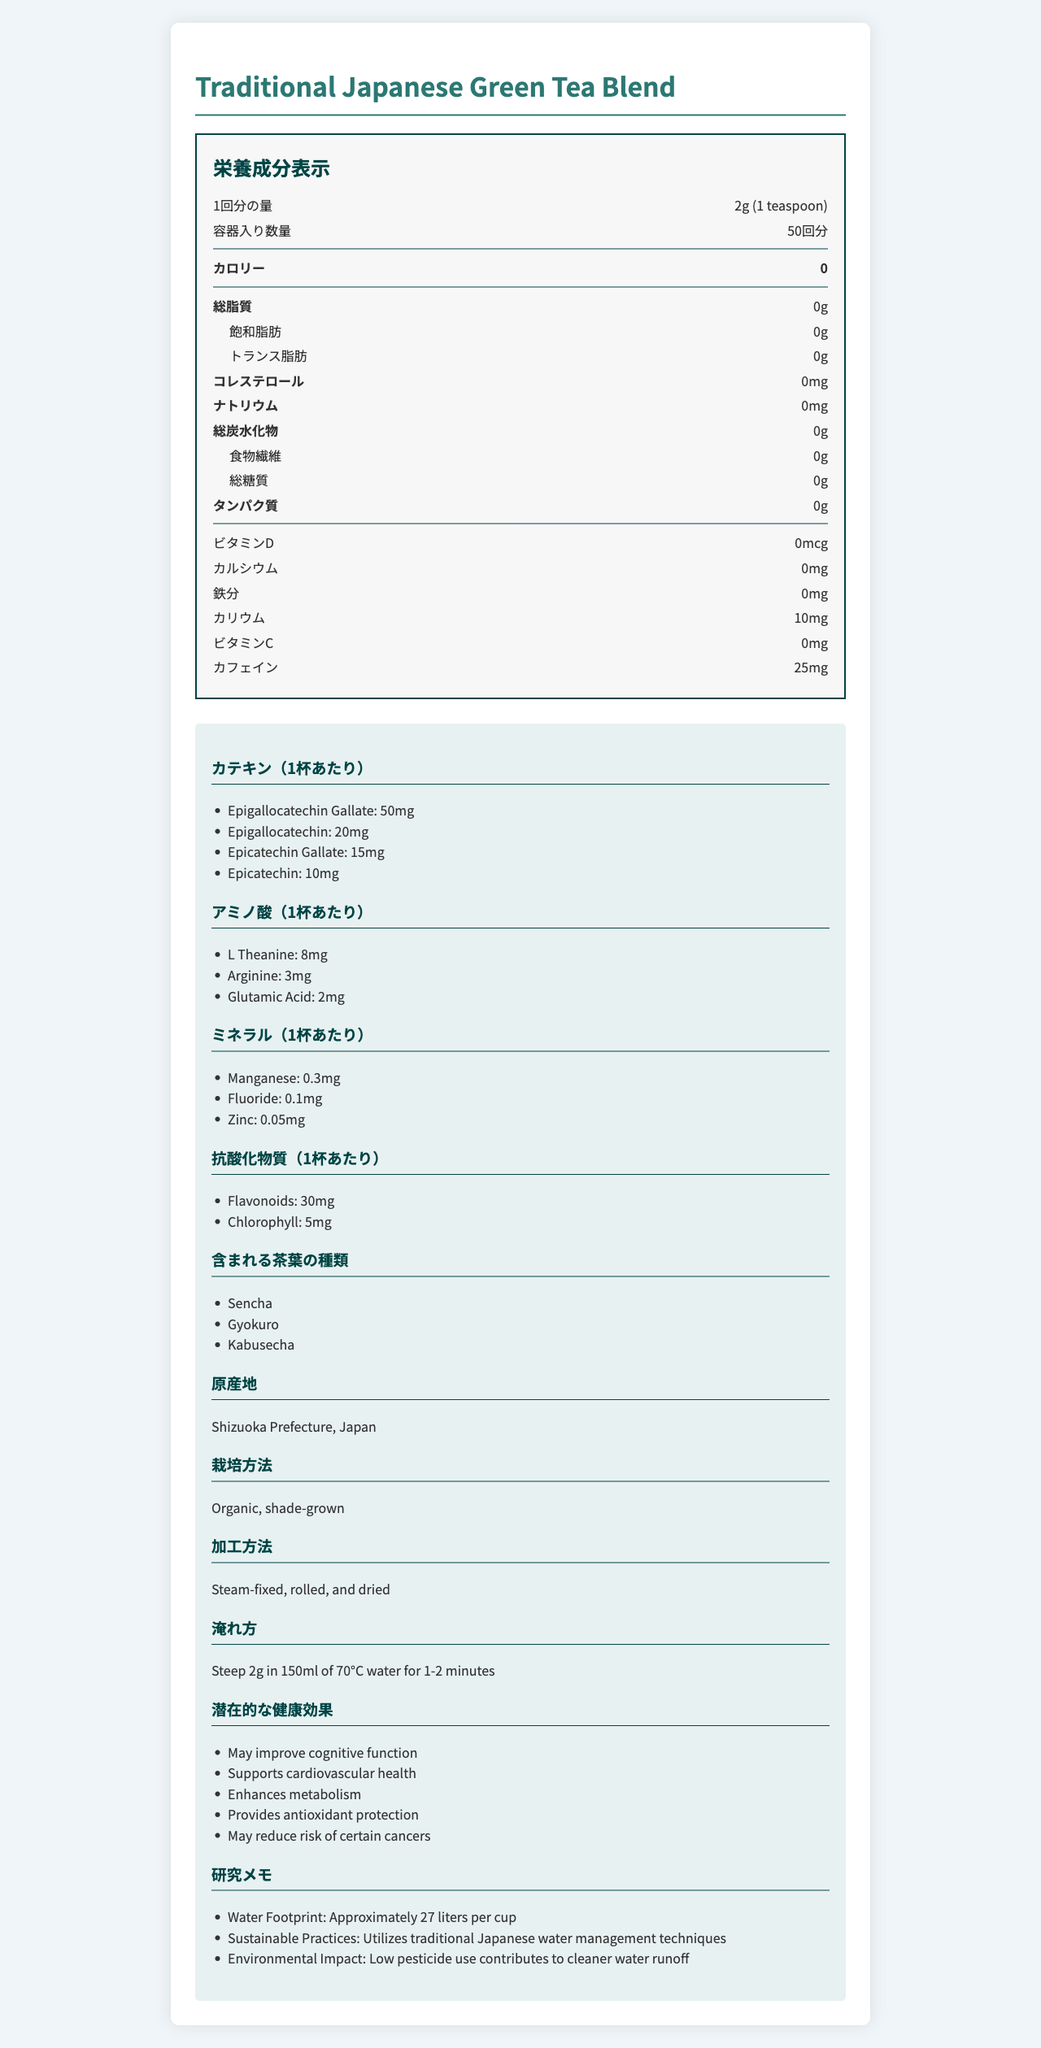what is the serving size of the Traditional Japanese Green Tea Blend? The serving size is clearly stated as "2g (1 teaspoon)" in the document.
Answer: 2g (1 teaspoon) how many servings are there per container? The document specifies "servings per container" as 50.
Answer: 50 how much caffeine is in one serving of the tea? The amount of caffeine per serving is listed as 25mg.
Answer: 25mg which varieties of tea are included in the blend? The document lists the varieties included: Sencha, Gyokuro, and Kabusecha.
Answer: Sencha, Gyokuro, Kabusecha what is the brewing temperature and steeping time recommended? The brewing instructions recommend steeping 2g in 150ml of 70°C water for 1-2 minutes.
Answer: 70°C for 1-2 minutes what are the potential health benefits mentioned for this tea? A. May improve cognitive function B. Provides antioxidant protection C. Enhances metabolism D. All of the above The document lists all these potential health benefits, including "May improve cognitive function," "Provides antioxidant protection," and "Enhances metabolism."
Answer: D how many milligrams of potassium are in one serving? A. 0 B. 10 C. 25 D. 50 The document lists potassium content per serving as 10mg.
Answer: B is the product organic? The document states the cultivation method as "Organic, shade-grown."
Answer: Yes does the tea contain any cholesterol? The document specifies 0mg cholesterol per serving.
Answer: No summarize the main nutritional components of the Traditional Japanese Green Tea Blend. This summary encapsulates the key nutritional and health-benefitting components of the tea blend as listed in the document.
Answer: The Traditional Japanese Green Tea Blend is a zero-calorie beverage containing no fat, cholesterol, sodium, carbohydrates, sugars, or protein. It has 10mg of potassium, 25mg of caffeine, rich catechins, amino acids, minerals, and antioxidants, making it beneficial for health. what is the water footprint of one cup of this tea? The document mentions a water footprint of approximately 27 liters per cup.
Answer: Approximately 27 liters per cup where is the tea produced? The document states the origin as Shizuoka Prefecture, Japan.
Answer: Shizuoka Prefecture, Japan how many grams of dietary fiber are present in one serving? The dietary fiber content per serving is listed as 0g in the document.
Answer: 0g what catechin is found in the highest amount in the tea? It lists epigallocatechin gallate (EGCG) at 50mg, which is higher than the other catechins listed.
Answer: Epigallocatechin gallate what are the sustainable practices mentioned in relation to the tea production? The document mentions the use of traditional Japanese water management techniques and low pesticide use.
Answer: Utilizes traditional Japanese water management techniques, low pesticide use what is the total amount of flavonoids per serving? The document lists flavonoids at 30mg per serving as part of the antioxidants.
Answer: 30mg were pesticides used in the production of this tea? The document only mentions "low pesticide use," but it does not specify whether pesticides were used at all or in what quantity.
Answer: Cannot be determined 